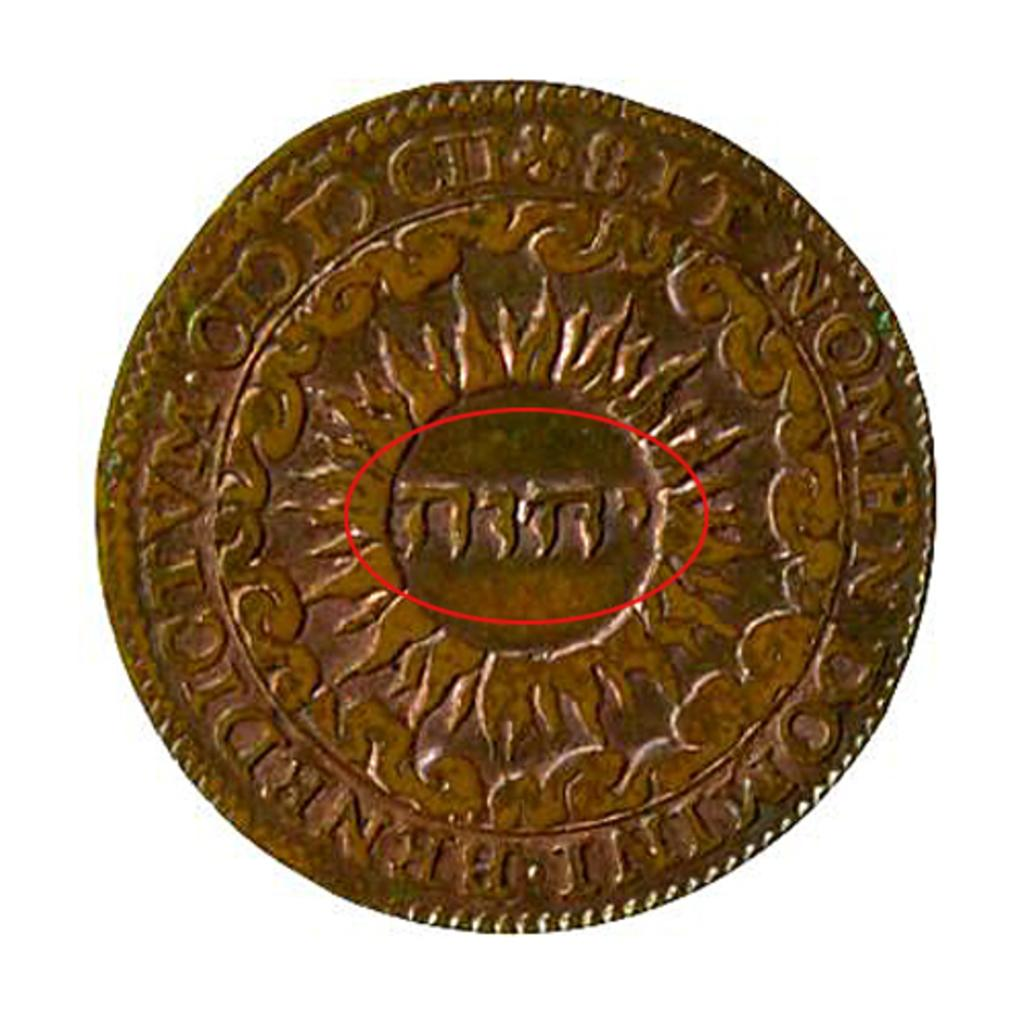What object is the main subject of the image? There is a coin in the image. What design can be seen on the coin? The coin has an emblem. What else can be found on the coin? Something is written on the coin. What color is the background of the image? The background of the image is white. How many mice are visible on the coin in the image? There are no mice present on the coin or in the image. What type of waste is being disposed of in the image? There is no waste present in the image; it features a coin with an emblem and writing. 